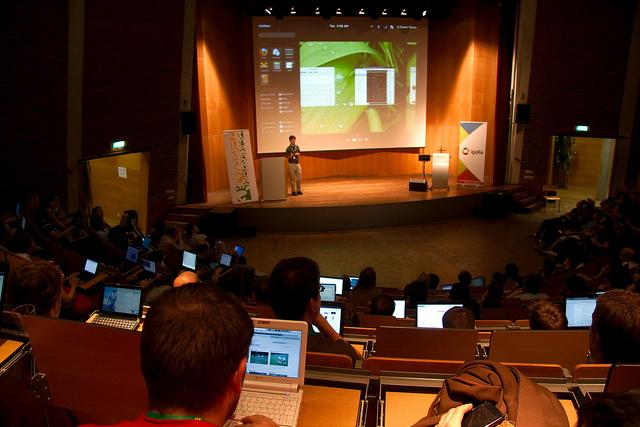What type of classroom could this be called?

Choices:
A) podium
B) amphitheater
C) stadium
D) enclave stadium 